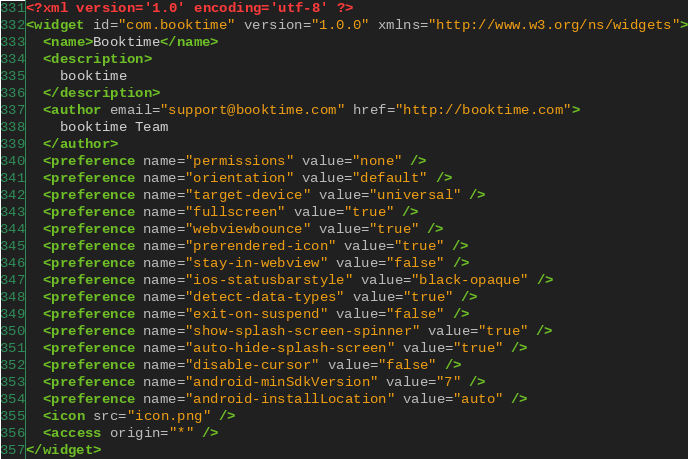<code> <loc_0><loc_0><loc_500><loc_500><_XML_><?xml version='1.0' encoding='utf-8' ?>
<widget id="com.booktime" version="1.0.0" xmlns="http://www.w3.org/ns/widgets">
  <name>Booktime</name>
  <description>
    booktime
  </description>
  <author email="support@booktime.com" href="http://booktime.com">
    booktime Team
  </author>
  <preference name="permissions" value="none" />
  <preference name="orientation" value="default" />
  <preference name="target-device" value="universal" />
  <preference name="fullscreen" value="true" />
  <preference name="webviewbounce" value="true" />
  <preference name="prerendered-icon" value="true" />
  <preference name="stay-in-webview" value="false" />
  <preference name="ios-statusbarstyle" value="black-opaque" />
  <preference name="detect-data-types" value="true" />
  <preference name="exit-on-suspend" value="false" />
  <preference name="show-splash-screen-spinner" value="true" />
  <preference name="auto-hide-splash-screen" value="true" />
  <preference name="disable-cursor" value="false" />
  <preference name="android-minSdkVersion" value="7" />
  <preference name="android-installLocation" value="auto" />
  <icon src="icon.png" />
  <access origin="*" />
</widget>
</code> 